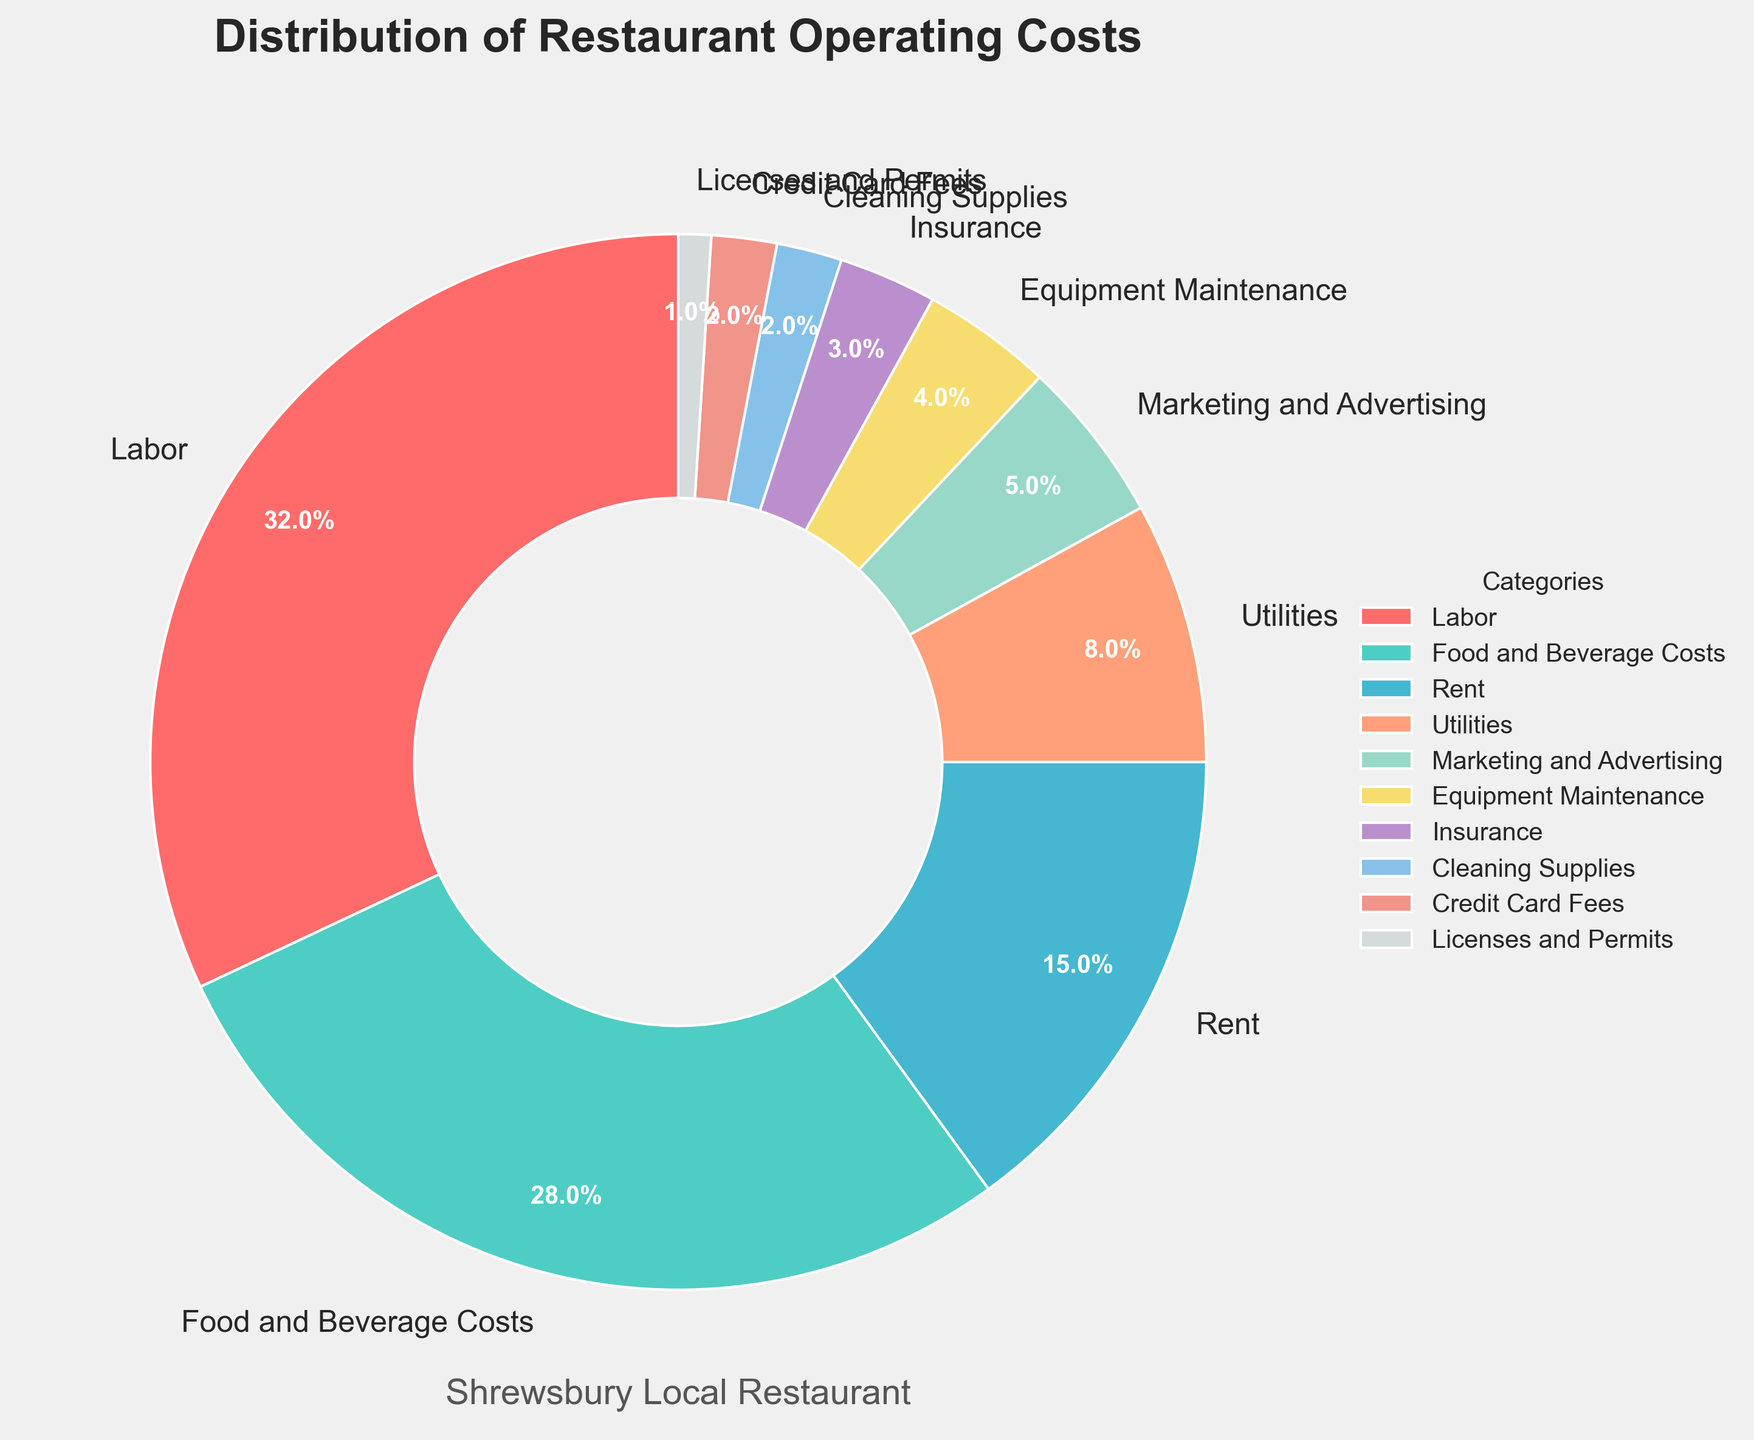What category has the highest percentage of operating costs? The category with the highest percentage can be identified by looking for the largest section of the pie chart. In this case, it's Labor, which constitutes 32% of the total operating costs.
Answer: Labor What is the combined percentage of Food and Beverage Costs and Rent? To find the combined percentage, sum the percentages of Food and Beverage Costs (28%) and Rent (15%). This results in 28 + 15 = 43%.
Answer: 43% What is the difference in percentage between Labor and Utilities? To find the difference, subtract the percentage of Utilities from the percentage of Labor. This is 32% - 8% = 24%.
Answer: 24% Which category represents the smallest portion of operating costs? The category with the smallest portion can be identified by finding the smallest section of the pie chart. In this case, it is Licenses and Permits, which is 1%.
Answer: Licenses and Permits What is the total percentage of the costs that are less than 5% each? Add up the percentages of Marketing and Advertising (5%), Equipment Maintenance (4%), Insurance (3%), Cleaning Supplies (2%), Credit Card Fees (2%), and Licenses and Permits (1%). The total is 5 + 4 + 3 + 2 + 2 + 1 = 17%.
Answer: 17% Is the percentage of Labor costs greater than the combined percentage of Rent and Utilities? First, sum the percentages of Rent (15%) and Utilities (8%), which equals 15 + 8 = 23%. Then, compare this with the percentage of Labor, which is 32%. Since 32% is greater than 23%, the answer is yes.
Answer: Yes How many categories have a percentage higher than 10%? By visually inspecting the pie chart, we identify which sections are larger than 10%: Labor (32%), Food and Beverage Costs (28%), and Rent (15%). This results in 3 categories.
Answer: 3 What is the visual color representation for Food and Beverage Costs? The visual color representation can be determined by looking at the pie chart and identifying the color segment labeled "Food and Beverage Costs." It is light green.
Answer: Light green What's the total percentage of all categories that are 8% or more? Sum the percentages of Labor (32%), Food and Beverage Costs (28%), Rent (15%), and Utilities (8%). The total is 32 + 28 + 15 + 8 = 83%.
Answer: 83% Is the percentage for Marketing and Advertising lower than the sum of Equipment Maintenance and Insurance? First, sum the percentages of Equipment Maintenance (4%) and Insurance (3%), which equals to 4 + 3 = 7%. Then compare this with the percentage for Marketing and Advertising, which is 5%. Since 5% is lower than 7%, the answer is yes.
Answer: Yes 